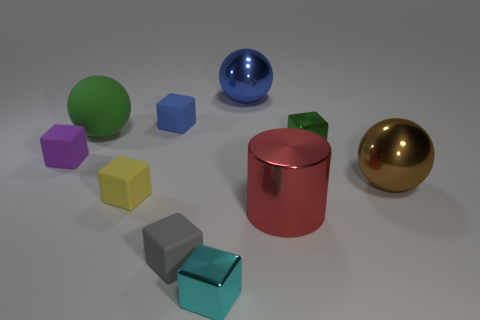What is the size of the blue object that is to the right of the gray rubber object?
Your response must be concise. Large. The gray matte cube has what size?
Ensure brevity in your answer.  Small. There is a green block; is its size the same as the metal ball that is behind the purple object?
Give a very brief answer. No. What color is the sphere in front of the large object left of the gray block?
Keep it short and to the point. Brown. Are there the same number of tiny metallic cubes to the right of the brown object and small metal cubes to the left of the cyan block?
Keep it short and to the point. Yes. Is the large object left of the small yellow cube made of the same material as the tiny blue block?
Your answer should be compact. Yes. What is the color of the tiny thing that is both in front of the yellow block and behind the tiny cyan shiny thing?
Give a very brief answer. Gray. There is a green matte object behind the large metallic cylinder; how many big green balls are in front of it?
Your response must be concise. 0. There is a tiny yellow object that is the same shape as the purple thing; what is it made of?
Give a very brief answer. Rubber. What is the color of the cylinder?
Keep it short and to the point. Red. 